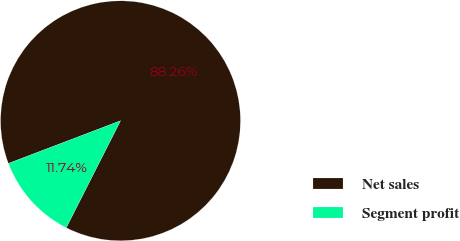Convert chart. <chart><loc_0><loc_0><loc_500><loc_500><pie_chart><fcel>Net sales<fcel>Segment profit<nl><fcel>88.26%<fcel>11.74%<nl></chart> 